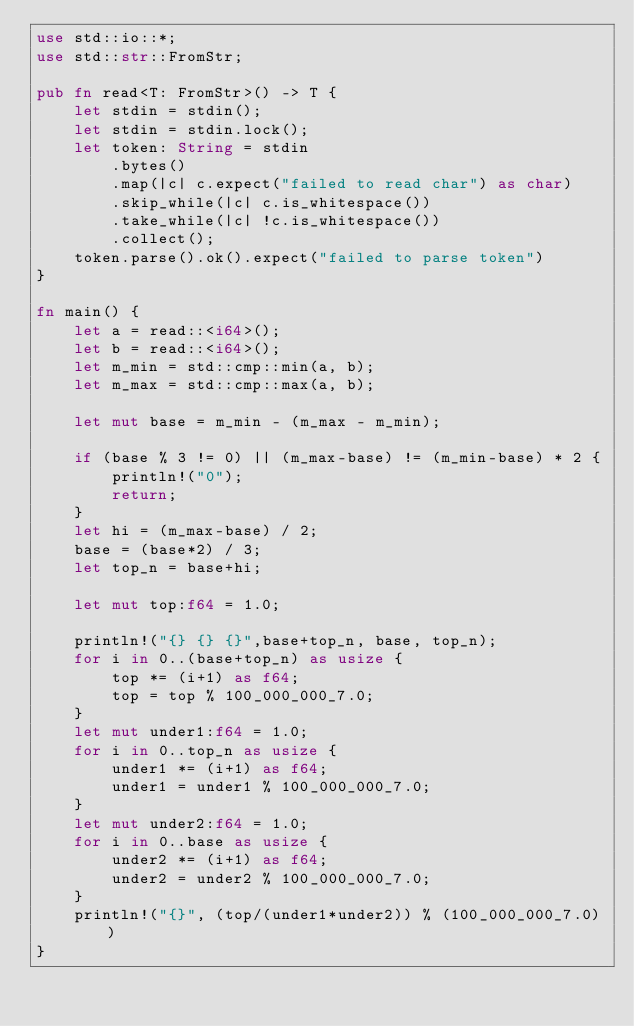Convert code to text. <code><loc_0><loc_0><loc_500><loc_500><_Rust_>use std::io::*;
use std::str::FromStr;

pub fn read<T: FromStr>() -> T {
    let stdin = stdin();
    let stdin = stdin.lock();
    let token: String = stdin
        .bytes()
        .map(|c| c.expect("failed to read char") as char)
        .skip_while(|c| c.is_whitespace())
        .take_while(|c| !c.is_whitespace())
        .collect();
    token.parse().ok().expect("failed to parse token")
}

fn main() {
    let a = read::<i64>();
    let b = read::<i64>();
    let m_min = std::cmp::min(a, b);
    let m_max = std::cmp::max(a, b);

    let mut base = m_min - (m_max - m_min);

    if (base % 3 != 0) || (m_max-base) != (m_min-base) * 2 {
        println!("0");
        return;
    }
    let hi = (m_max-base) / 2;
    base = (base*2) / 3;
    let top_n = base+hi;
    
    let mut top:f64 = 1.0;

    println!("{} {} {}",base+top_n, base, top_n);
    for i in 0..(base+top_n) as usize {
        top *= (i+1) as f64;
        top = top % 100_000_000_7.0;
    }
    let mut under1:f64 = 1.0;
    for i in 0..top_n as usize {
        under1 *= (i+1) as f64;
        under1 = under1 % 100_000_000_7.0;
    }
    let mut under2:f64 = 1.0;
    for i in 0..base as usize {
        under2 *= (i+1) as f64;
        under2 = under2 % 100_000_000_7.0;
    }
    println!("{}", (top/(under1*under2)) % (100_000_000_7.0))
}
</code> 